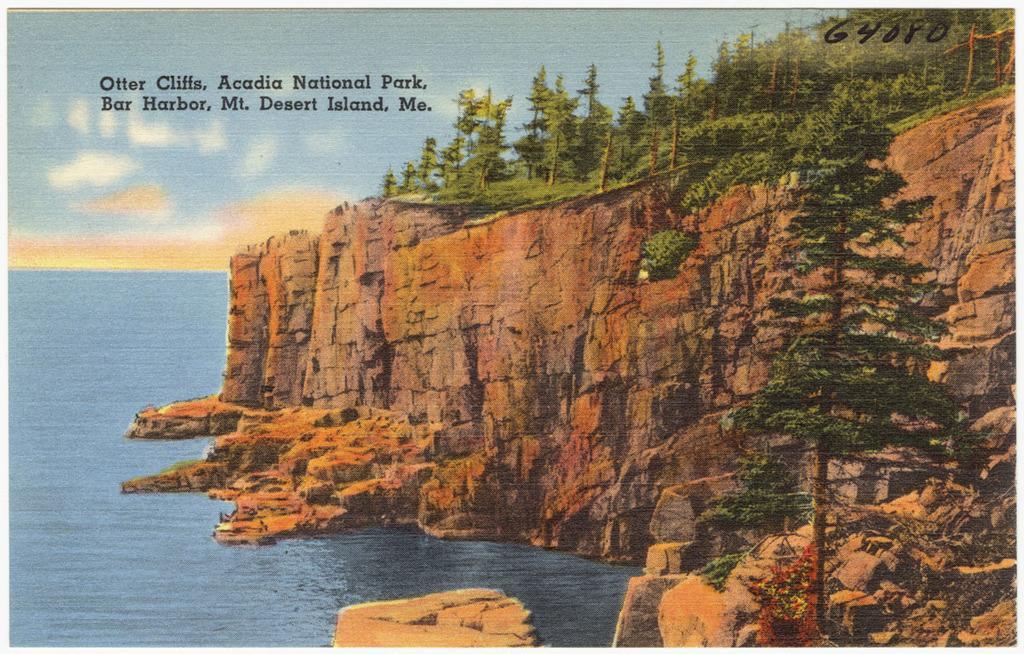Can you describe this image briefly? This is a picture of a poster , where there is a hill, trees, water ,sky , and there are some words on the poster. 